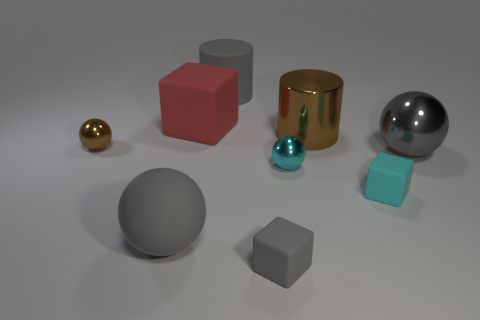Subtract all tiny brown spheres. How many spheres are left? 3 Subtract 1 balls. How many balls are left? 3 Subtract all red spheres. Subtract all purple cylinders. How many spheres are left? 4 Add 1 tiny purple things. How many objects exist? 10 Subtract all spheres. How many objects are left? 5 Subtract all tiny cyan metallic spheres. Subtract all tiny cyan blocks. How many objects are left? 7 Add 6 brown metallic objects. How many brown metallic objects are left? 8 Add 8 cyan spheres. How many cyan spheres exist? 9 Subtract 1 brown cylinders. How many objects are left? 8 